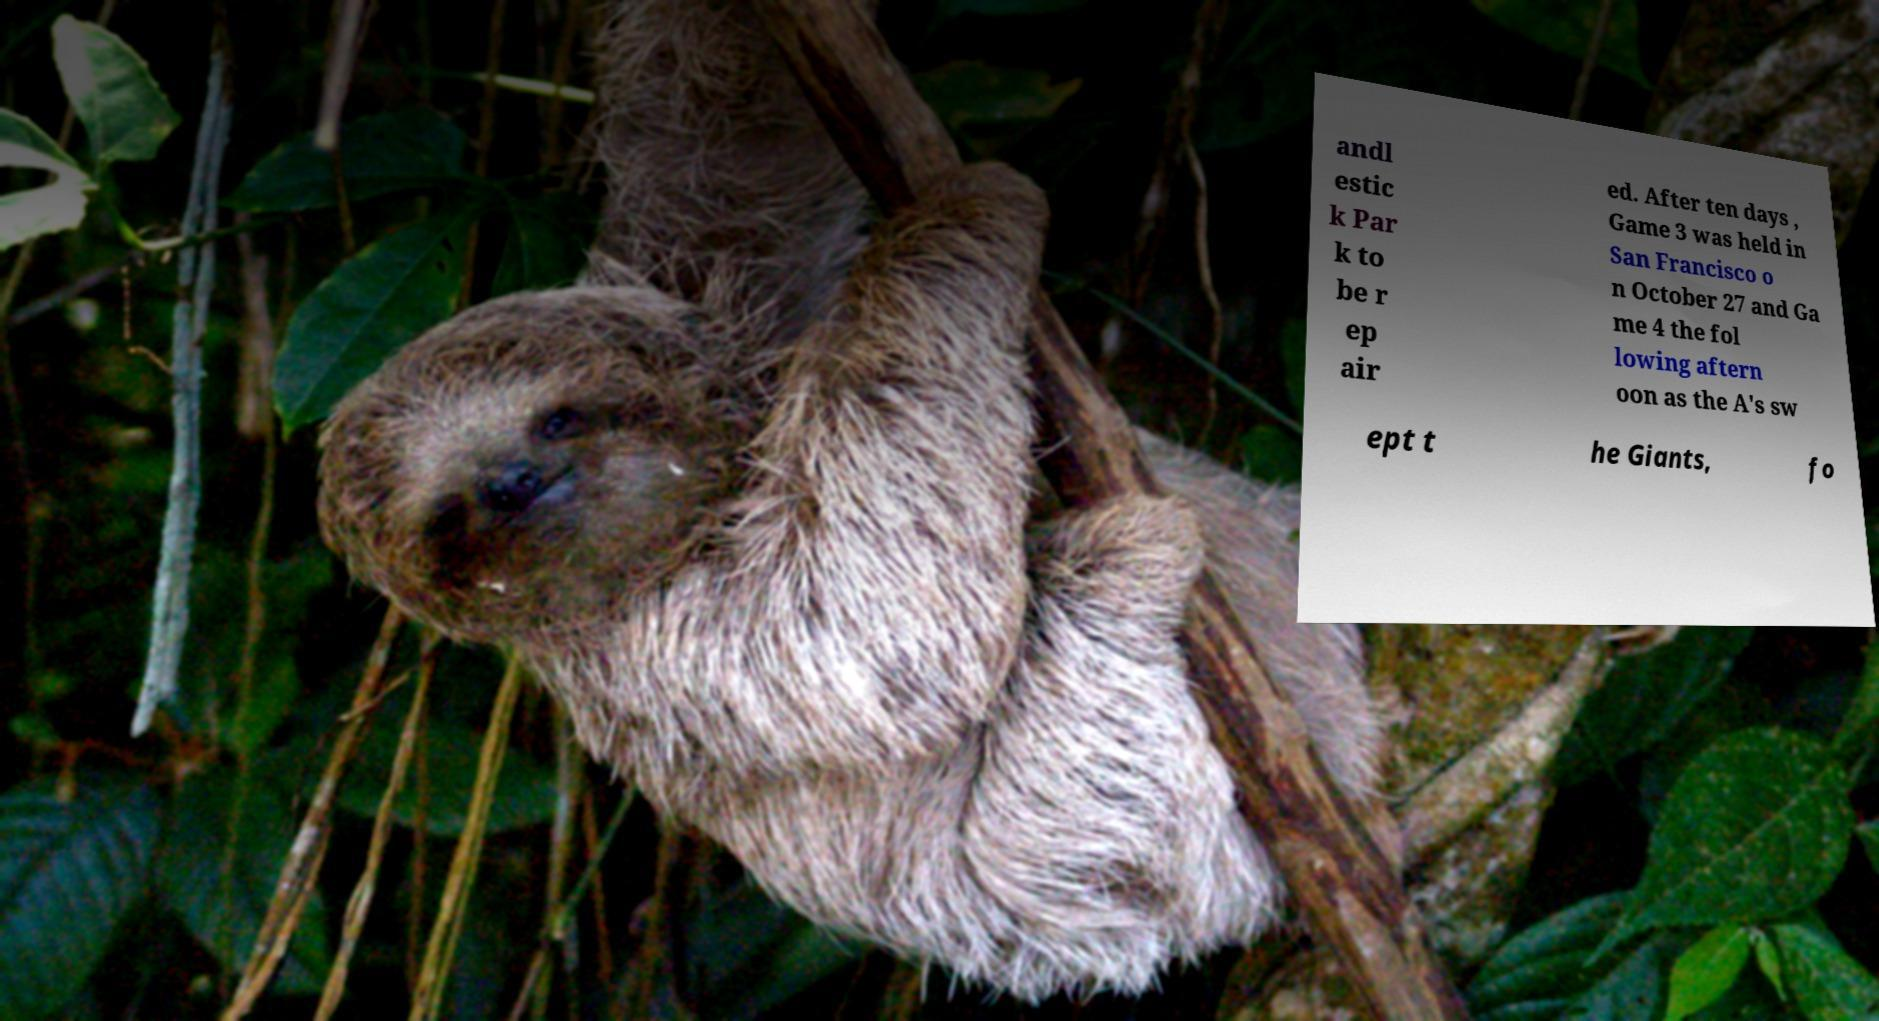For documentation purposes, I need the text within this image transcribed. Could you provide that? andl estic k Par k to be r ep air ed. After ten days , Game 3 was held in San Francisco o n October 27 and Ga me 4 the fol lowing aftern oon as the A's sw ept t he Giants, fo 